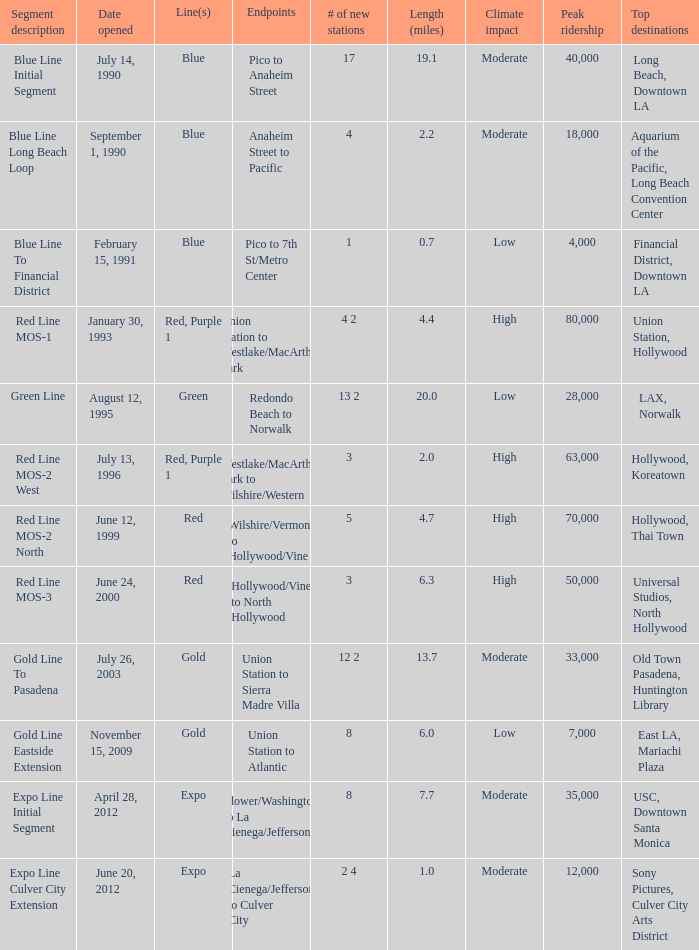How many new stations have a lenght (miles) of 6.0? 1.0. 